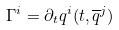Convert formula to latex. <formula><loc_0><loc_0><loc_500><loc_500>\Gamma ^ { i } = \partial _ { t } q ^ { i } ( t , \overline { q } ^ { j } )</formula> 